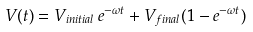Convert formula to latex. <formula><loc_0><loc_0><loc_500><loc_500>V ( t ) = V _ { i n i t i a l } \, e ^ { - \omega t } + V _ { f i n a l } ( 1 - e ^ { - \omega t } )</formula> 